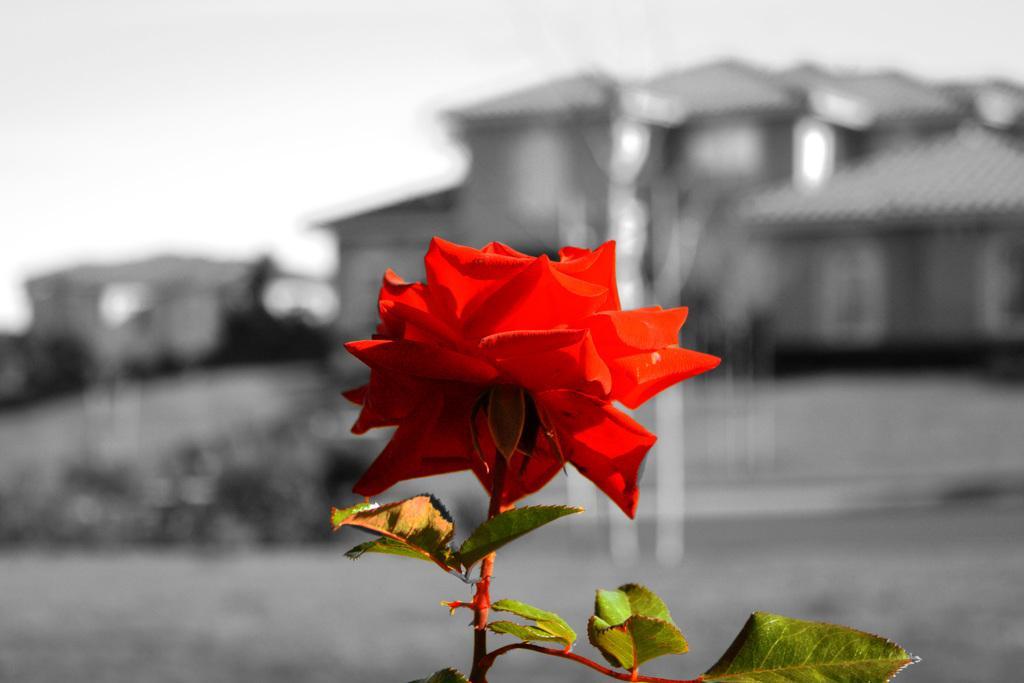Could you give a brief overview of what you see in this image? In this picture we can see leaves and a red color flower in the front, in the background there are houses, we can see a blurry background. 